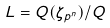Convert formula to latex. <formula><loc_0><loc_0><loc_500><loc_500>L = Q ( \zeta _ { p ^ { n } } ) / Q</formula> 